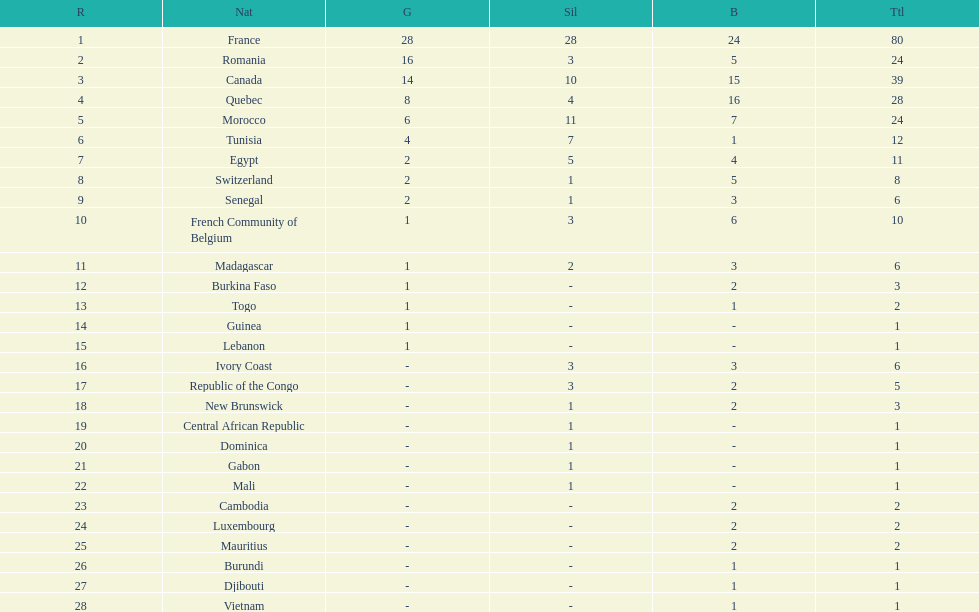How many more medals did egypt win than ivory coast? 5. 